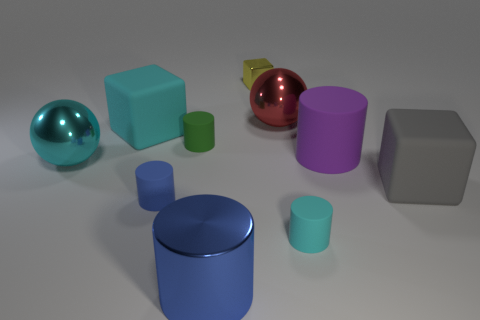There is a cube that is both right of the small green cylinder and on the left side of the purple rubber thing; what is its material?
Offer a terse response. Metal. Does the purple thing have the same shape as the metal object that is in front of the large cyan metallic ball?
Offer a very short reply. Yes. What material is the big object on the left side of the big matte thing that is left of the cube behind the cyan rubber cube?
Make the answer very short. Metal. How many other things are the same size as the green cylinder?
Ensure brevity in your answer.  3. Do the tiny shiny block and the big shiny cylinder have the same color?
Offer a terse response. No. There is a shiny thing behind the ball that is right of the big blue thing; how many tiny cubes are behind it?
Provide a succinct answer. 0. The large sphere that is to the right of the metal object that is in front of the tiny blue rubber object is made of what material?
Offer a very short reply. Metal. Are there any other large shiny things that have the same shape as the big purple object?
Your answer should be very brief. Yes. The other block that is the same size as the gray block is what color?
Ensure brevity in your answer.  Cyan. How many objects are blocks that are right of the small metal thing or spheres that are in front of the big cyan rubber block?
Offer a very short reply. 2. 